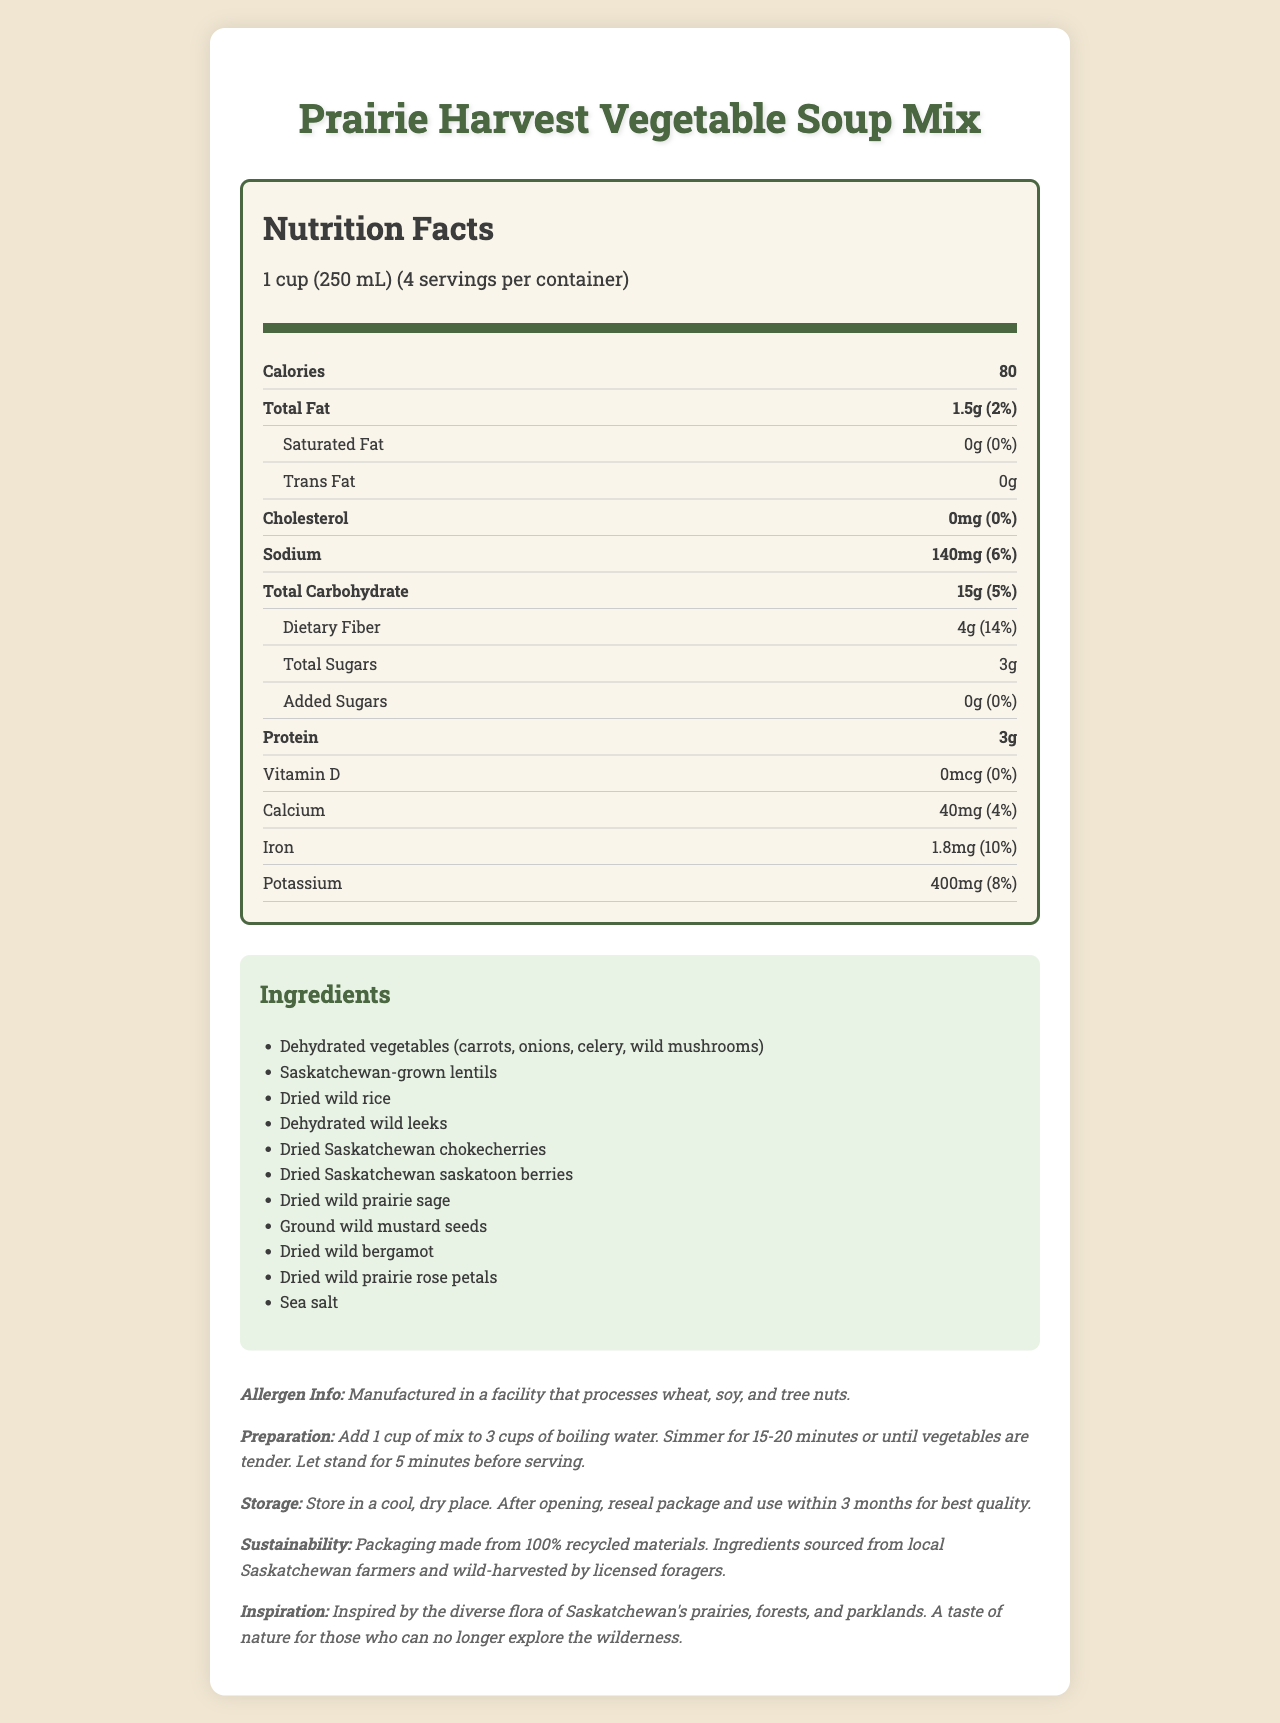what is the serving size? The document states that the serving size is "1 cup (250 mL)".
Answer: 1 cup (250 mL) how many calories are there per serving? The document lists "80" calories per serving.
Answer: 80 how many servings are there per container? It is mentioned in the document that there are 4 servings per container.
Answer: 4 what is the amount of total fat per serving? The document specifies that the total fat per serving is "1.5g".
Answer: 1.5g what are the ingredients of the soup mix? The list of ingredients is clearly provided in the document under the "Ingredients" section.
Answer: Dehydrated vegetables (carrots, onions, celery, wild mushrooms), Saskatchewan-grown lentils, Dried wild rice, Dehydrated wild leeks, Dried Saskatchewan chokecherries, Dried Saskatchewan saskatoon berries, Dried wild prairie sage, Ground wild mustard seeds, Dried wild bergamot, Dried wild prairie rose petals, Sea salt what percentage of daily value for dietary fiber does one serving cover? The document states the daily value for dietary fiber is "14%" per serving.
Answer: 14% which of the following is not an ingredient in the soup mix? A. Dehydrated wild leeks B. Dried wild bergamot C. Fresh tomatoes D. Dried Saskatchewan chokecherries The ingredients in the list include Dehydrated wild leeks, Dried wild bergamot, and Dried Saskatchewan chokecherries, but not Fresh tomatoes.
Answer: C. Fresh tomatoes what is the sodium content per serving? A. 140mg B. 150mg C. 160mg D. 170mg The document lists the sodium content per serving as "140mg".
Answer: A. 140mg is there any added sugar in the soup mix? The document specifies "0g" of added sugars, meaning there is no added sugar.
Answer: No are there any allergens mentioned for the product? The allergen information states: "Manufactured in a facility that processes wheat, soy, and tree nuts."
Answer: Yes summarize the main idea of the document. The document offers comprehensive details about the Prairie Harvest Vegetable Soup Mix, highlighting its nutritional value, local ingredients, allergen precautions, cooking guidelines, and its sustainability aspects as well as the inspiration from Saskatchewan's diverse flora.
Answer: The document provides detailed information on the nutritional facts, ingredients, allergen information, preparation and storage instructions, sustainability, and inspiration behind the Prairie Harvest Vegetable Soup Mix, which features local Saskatchewan flora. what is the total carbohydrate amount per serving? The document indicates that the total carbohydrate amount per serving is "15g".
Answer: 15g how do you prepare the soup mix? The preparation instructions specify to add 1 cup of the mix to 3 cups of boiling water, simmer for 15-20 minutes, and let stand for 5 minutes before serving.
Answer: Add 1 cup of mix to 3 cups of boiling water. Simmer for 15-20 minutes or until vegetables are tender. Let stand for 5 minutes before serving. where are the ingredients sourced from? The sustainability note mentions that the ingredients are sourced from local Saskatchewan farmers and are wild-harvested by licensed foragers.
Answer: Local Saskatchewan farmers and wild-harvested by licensed foragers what is the daily value percentage of protein per serving? The document does not provide a daily value percentage for protein, only the amount which is 3g.
Answer: Not listed explicitly how much iron does one serving provide? The document specifies that one serving provides "1.8mg" of iron.
Answer: 1.8mg what is the sustainability note mentioned in the document? The sustainability note states that the packaging is made from recycled materials and the ingredients are locally sourced and wild-harvested.
Answer: Packaging made from 100% recycled materials. Ingredients sourced from local Saskatchewan farmers and wild-harvested by licensed foragers. does the product contain any cholesterol? The document lists "0mg" of cholesterol per serving.
Answer: No how much calcium is in one serving? It is mentioned in the document that one serving contains "40mg" of calcium.
Answer: 40mg what inspired the creation of this soup mix? The inspiration note in the document mentions that the soup mix is inspired by the diverse flora of Saskatchewan and aims to provide a taste of nature for those who can no longer explore the wilderness.
Answer: Inspired by the diverse flora of Saskatchewan's prairies, forests, and parklands. A taste of nature for those who can no longer explore the wilderness. 